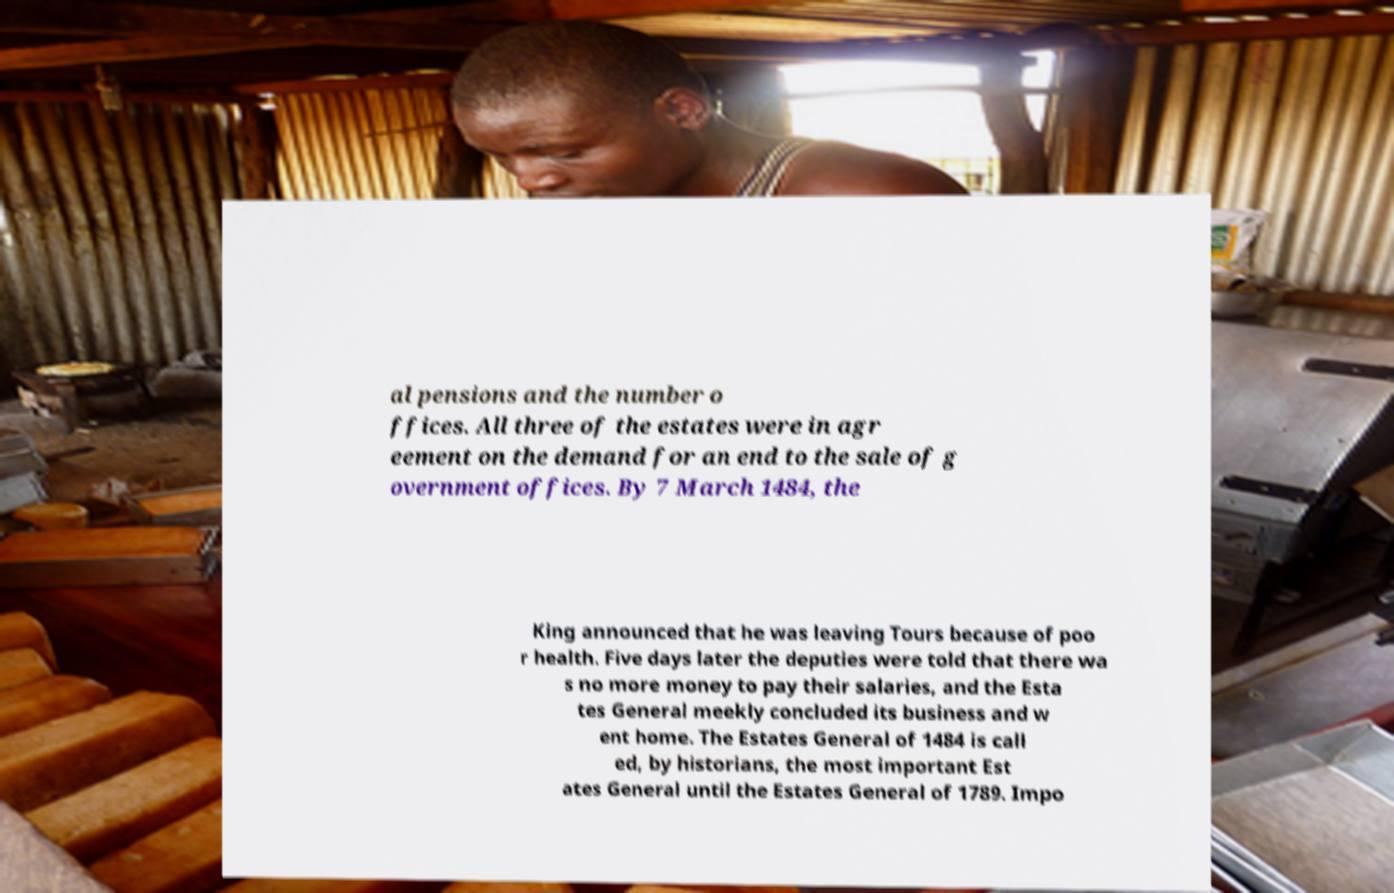Can you read and provide the text displayed in the image?This photo seems to have some interesting text. Can you extract and type it out for me? al pensions and the number o ffices. All three of the estates were in agr eement on the demand for an end to the sale of g overnment offices. By 7 March 1484, the King announced that he was leaving Tours because of poo r health. Five days later the deputies were told that there wa s no more money to pay their salaries, and the Esta tes General meekly concluded its business and w ent home. The Estates General of 1484 is call ed, by historians, the most important Est ates General until the Estates General of 1789. Impo 